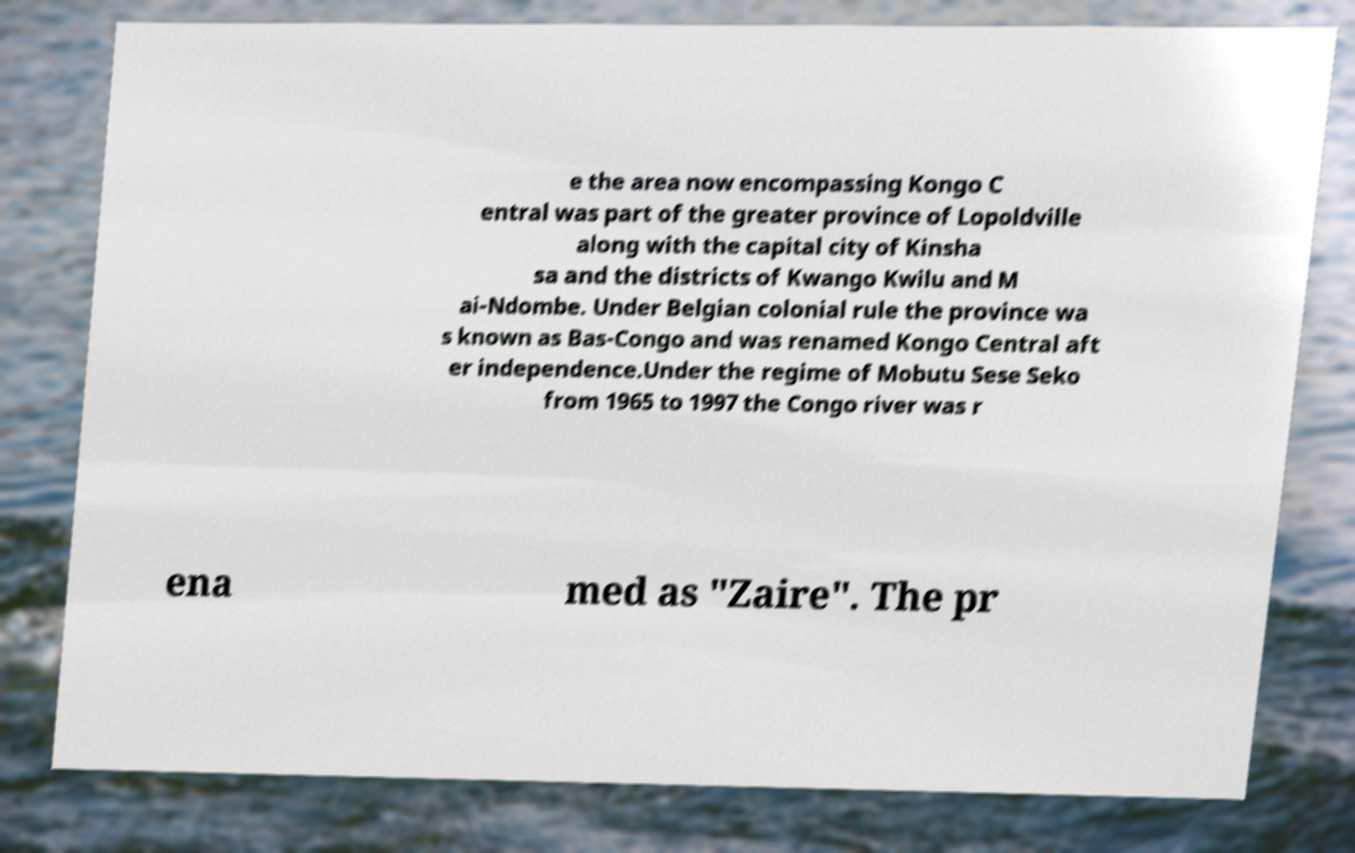Can you accurately transcribe the text from the provided image for me? e the area now encompassing Kongo C entral was part of the greater province of Lopoldville along with the capital city of Kinsha sa and the districts of Kwango Kwilu and M ai-Ndombe. Under Belgian colonial rule the province wa s known as Bas-Congo and was renamed Kongo Central aft er independence.Under the regime of Mobutu Sese Seko from 1965 to 1997 the Congo river was r ena med as "Zaire". The pr 